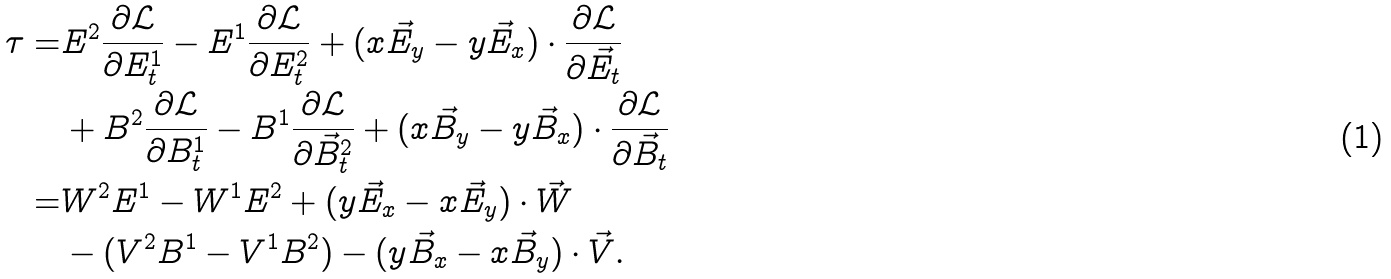Convert formula to latex. <formula><loc_0><loc_0><loc_500><loc_500>\tau = & E ^ { 2 } \frac { \partial \mathcal { L } } { \partial E ^ { 1 } _ { t } } - E ^ { 1 } \frac { \partial \mathcal { L } } { \partial E ^ { 2 } _ { t } } + ( x \vec { E } _ { y } - y \vec { E } _ { x } ) \cdot \frac { \partial \mathcal { L } } { \partial \vec { E } _ { t } } \\ & + B ^ { 2 } \frac { \partial \mathcal { L } } { \partial B ^ { 1 } _ { t } } - B ^ { 1 } \frac { \partial \mathcal { L } } { \partial \vec { B } ^ { 2 } _ { t } } + ( x \vec { B } _ { y } - y \vec { B } _ { x } ) \cdot \frac { \partial \mathcal { L } } { \partial \vec { B } _ { t } } \\ = & W ^ { 2 } E ^ { 1 } - W ^ { 1 } E ^ { 2 } + ( y \vec { E } _ { x } - x \vec { E } _ { y } ) \cdot \vec { W } \\ & - ( V ^ { 2 } B ^ { 1 } - V ^ { 1 } B ^ { 2 } ) - ( y \vec { B } _ { x } - x \vec { B } _ { y } ) \cdot \vec { V } .</formula> 